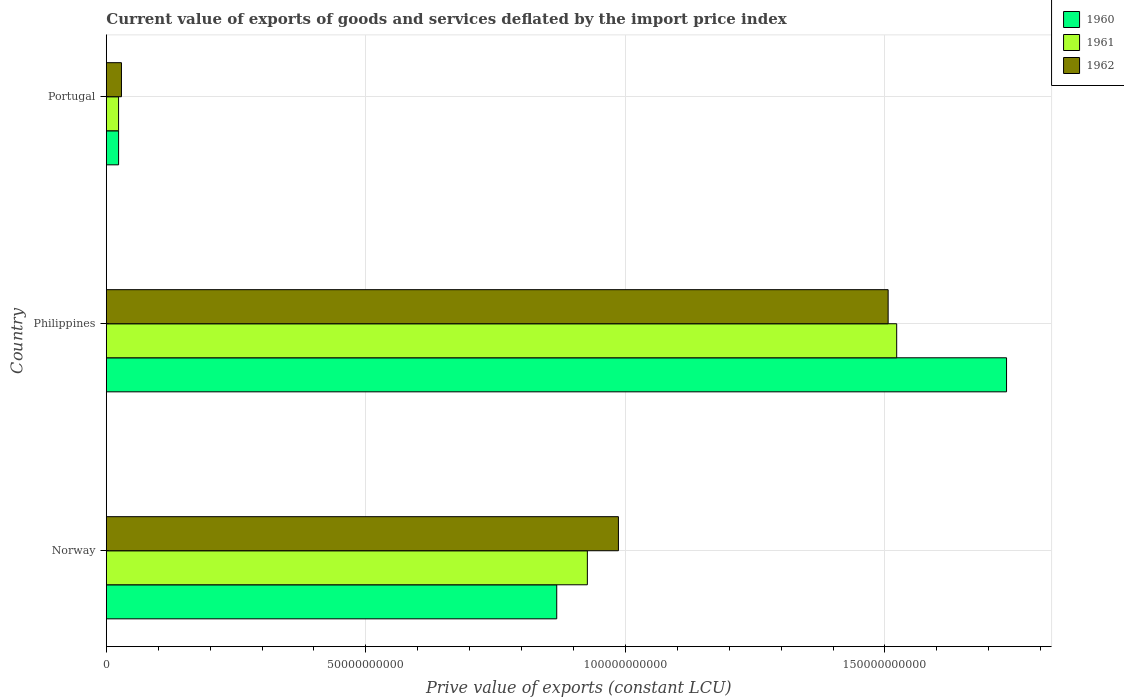How many different coloured bars are there?
Your answer should be compact. 3. Are the number of bars on each tick of the Y-axis equal?
Your answer should be very brief. Yes. How many bars are there on the 3rd tick from the top?
Your answer should be very brief. 3. What is the prive value of exports in 1962 in Portugal?
Your answer should be very brief. 2.91e+09. Across all countries, what is the maximum prive value of exports in 1961?
Ensure brevity in your answer.  1.52e+11. Across all countries, what is the minimum prive value of exports in 1962?
Offer a very short reply. 2.91e+09. In which country was the prive value of exports in 1960 maximum?
Offer a very short reply. Philippines. In which country was the prive value of exports in 1961 minimum?
Offer a very short reply. Portugal. What is the total prive value of exports in 1961 in the graph?
Your answer should be very brief. 2.47e+11. What is the difference between the prive value of exports in 1961 in Norway and that in Philippines?
Your answer should be compact. -5.96e+1. What is the difference between the prive value of exports in 1962 in Philippines and the prive value of exports in 1960 in Portugal?
Offer a terse response. 1.48e+11. What is the average prive value of exports in 1962 per country?
Keep it short and to the point. 8.41e+1. What is the difference between the prive value of exports in 1960 and prive value of exports in 1961 in Portugal?
Provide a succinct answer. 2.01e+06. What is the ratio of the prive value of exports in 1962 in Philippines to that in Portugal?
Your answer should be compact. 51.71. Is the prive value of exports in 1962 in Norway less than that in Philippines?
Your response must be concise. Yes. What is the difference between the highest and the second highest prive value of exports in 1961?
Offer a very short reply. 5.96e+1. What is the difference between the highest and the lowest prive value of exports in 1962?
Ensure brevity in your answer.  1.48e+11. How many countries are there in the graph?
Your answer should be very brief. 3. What is the difference between two consecutive major ticks on the X-axis?
Make the answer very short. 5.00e+1. What is the title of the graph?
Your answer should be compact. Current value of exports of goods and services deflated by the import price index. What is the label or title of the X-axis?
Your answer should be compact. Prive value of exports (constant LCU). What is the label or title of the Y-axis?
Your answer should be very brief. Country. What is the Prive value of exports (constant LCU) in 1960 in Norway?
Ensure brevity in your answer.  8.68e+1. What is the Prive value of exports (constant LCU) in 1961 in Norway?
Offer a terse response. 9.27e+1. What is the Prive value of exports (constant LCU) of 1962 in Norway?
Offer a terse response. 9.87e+1. What is the Prive value of exports (constant LCU) of 1960 in Philippines?
Offer a terse response. 1.73e+11. What is the Prive value of exports (constant LCU) of 1961 in Philippines?
Your response must be concise. 1.52e+11. What is the Prive value of exports (constant LCU) in 1962 in Philippines?
Your answer should be very brief. 1.51e+11. What is the Prive value of exports (constant LCU) of 1960 in Portugal?
Provide a short and direct response. 2.36e+09. What is the Prive value of exports (constant LCU) of 1961 in Portugal?
Offer a terse response. 2.36e+09. What is the Prive value of exports (constant LCU) in 1962 in Portugal?
Offer a terse response. 2.91e+09. Across all countries, what is the maximum Prive value of exports (constant LCU) of 1960?
Offer a terse response. 1.73e+11. Across all countries, what is the maximum Prive value of exports (constant LCU) of 1961?
Provide a short and direct response. 1.52e+11. Across all countries, what is the maximum Prive value of exports (constant LCU) of 1962?
Make the answer very short. 1.51e+11. Across all countries, what is the minimum Prive value of exports (constant LCU) of 1960?
Give a very brief answer. 2.36e+09. Across all countries, what is the minimum Prive value of exports (constant LCU) in 1961?
Make the answer very short. 2.36e+09. Across all countries, what is the minimum Prive value of exports (constant LCU) of 1962?
Provide a short and direct response. 2.91e+09. What is the total Prive value of exports (constant LCU) of 1960 in the graph?
Make the answer very short. 2.63e+11. What is the total Prive value of exports (constant LCU) of 1961 in the graph?
Provide a short and direct response. 2.47e+11. What is the total Prive value of exports (constant LCU) of 1962 in the graph?
Your answer should be compact. 2.52e+11. What is the difference between the Prive value of exports (constant LCU) of 1960 in Norway and that in Philippines?
Make the answer very short. -8.67e+1. What is the difference between the Prive value of exports (constant LCU) in 1961 in Norway and that in Philippines?
Your answer should be compact. -5.96e+1. What is the difference between the Prive value of exports (constant LCU) of 1962 in Norway and that in Philippines?
Your response must be concise. -5.20e+1. What is the difference between the Prive value of exports (constant LCU) of 1960 in Norway and that in Portugal?
Offer a very short reply. 8.44e+1. What is the difference between the Prive value of exports (constant LCU) in 1961 in Norway and that in Portugal?
Provide a short and direct response. 9.03e+1. What is the difference between the Prive value of exports (constant LCU) in 1962 in Norway and that in Portugal?
Your answer should be very brief. 9.57e+1. What is the difference between the Prive value of exports (constant LCU) of 1960 in Philippines and that in Portugal?
Your response must be concise. 1.71e+11. What is the difference between the Prive value of exports (constant LCU) of 1961 in Philippines and that in Portugal?
Ensure brevity in your answer.  1.50e+11. What is the difference between the Prive value of exports (constant LCU) of 1962 in Philippines and that in Portugal?
Your response must be concise. 1.48e+11. What is the difference between the Prive value of exports (constant LCU) in 1960 in Norway and the Prive value of exports (constant LCU) in 1961 in Philippines?
Give a very brief answer. -6.55e+1. What is the difference between the Prive value of exports (constant LCU) in 1960 in Norway and the Prive value of exports (constant LCU) in 1962 in Philippines?
Provide a short and direct response. -6.39e+1. What is the difference between the Prive value of exports (constant LCU) of 1961 in Norway and the Prive value of exports (constant LCU) of 1962 in Philippines?
Ensure brevity in your answer.  -5.79e+1. What is the difference between the Prive value of exports (constant LCU) in 1960 in Norway and the Prive value of exports (constant LCU) in 1961 in Portugal?
Provide a short and direct response. 8.44e+1. What is the difference between the Prive value of exports (constant LCU) in 1960 in Norway and the Prive value of exports (constant LCU) in 1962 in Portugal?
Offer a very short reply. 8.39e+1. What is the difference between the Prive value of exports (constant LCU) in 1961 in Norway and the Prive value of exports (constant LCU) in 1962 in Portugal?
Your response must be concise. 8.98e+1. What is the difference between the Prive value of exports (constant LCU) of 1960 in Philippines and the Prive value of exports (constant LCU) of 1961 in Portugal?
Provide a succinct answer. 1.71e+11. What is the difference between the Prive value of exports (constant LCU) in 1960 in Philippines and the Prive value of exports (constant LCU) in 1962 in Portugal?
Make the answer very short. 1.71e+11. What is the difference between the Prive value of exports (constant LCU) in 1961 in Philippines and the Prive value of exports (constant LCU) in 1962 in Portugal?
Make the answer very short. 1.49e+11. What is the average Prive value of exports (constant LCU) in 1960 per country?
Ensure brevity in your answer.  8.75e+1. What is the average Prive value of exports (constant LCU) in 1961 per country?
Make the answer very short. 8.24e+1. What is the average Prive value of exports (constant LCU) in 1962 per country?
Offer a very short reply. 8.41e+1. What is the difference between the Prive value of exports (constant LCU) of 1960 and Prive value of exports (constant LCU) of 1961 in Norway?
Offer a very short reply. -5.90e+09. What is the difference between the Prive value of exports (constant LCU) of 1960 and Prive value of exports (constant LCU) of 1962 in Norway?
Your answer should be compact. -1.19e+1. What is the difference between the Prive value of exports (constant LCU) of 1961 and Prive value of exports (constant LCU) of 1962 in Norway?
Your answer should be very brief. -5.98e+09. What is the difference between the Prive value of exports (constant LCU) of 1960 and Prive value of exports (constant LCU) of 1961 in Philippines?
Provide a succinct answer. 2.12e+1. What is the difference between the Prive value of exports (constant LCU) of 1960 and Prive value of exports (constant LCU) of 1962 in Philippines?
Offer a terse response. 2.28e+1. What is the difference between the Prive value of exports (constant LCU) in 1961 and Prive value of exports (constant LCU) in 1962 in Philippines?
Ensure brevity in your answer.  1.65e+09. What is the difference between the Prive value of exports (constant LCU) of 1960 and Prive value of exports (constant LCU) of 1961 in Portugal?
Your answer should be compact. 2.01e+06. What is the difference between the Prive value of exports (constant LCU) of 1960 and Prive value of exports (constant LCU) of 1962 in Portugal?
Your answer should be compact. -5.51e+08. What is the difference between the Prive value of exports (constant LCU) in 1961 and Prive value of exports (constant LCU) in 1962 in Portugal?
Your answer should be compact. -5.53e+08. What is the ratio of the Prive value of exports (constant LCU) of 1960 in Norway to that in Philippines?
Your answer should be very brief. 0.5. What is the ratio of the Prive value of exports (constant LCU) of 1961 in Norway to that in Philippines?
Offer a terse response. 0.61. What is the ratio of the Prive value of exports (constant LCU) of 1962 in Norway to that in Philippines?
Give a very brief answer. 0.66. What is the ratio of the Prive value of exports (constant LCU) of 1960 in Norway to that in Portugal?
Offer a terse response. 36.73. What is the ratio of the Prive value of exports (constant LCU) of 1961 in Norway to that in Portugal?
Your answer should be very brief. 39.27. What is the ratio of the Prive value of exports (constant LCU) in 1962 in Norway to that in Portugal?
Give a very brief answer. 33.87. What is the ratio of the Prive value of exports (constant LCU) of 1960 in Philippines to that in Portugal?
Your response must be concise. 73.42. What is the ratio of the Prive value of exports (constant LCU) of 1961 in Philippines to that in Portugal?
Offer a terse response. 64.52. What is the ratio of the Prive value of exports (constant LCU) of 1962 in Philippines to that in Portugal?
Ensure brevity in your answer.  51.71. What is the difference between the highest and the second highest Prive value of exports (constant LCU) in 1960?
Your answer should be compact. 8.67e+1. What is the difference between the highest and the second highest Prive value of exports (constant LCU) in 1961?
Provide a succinct answer. 5.96e+1. What is the difference between the highest and the second highest Prive value of exports (constant LCU) in 1962?
Your response must be concise. 5.20e+1. What is the difference between the highest and the lowest Prive value of exports (constant LCU) in 1960?
Provide a short and direct response. 1.71e+11. What is the difference between the highest and the lowest Prive value of exports (constant LCU) in 1961?
Make the answer very short. 1.50e+11. What is the difference between the highest and the lowest Prive value of exports (constant LCU) of 1962?
Ensure brevity in your answer.  1.48e+11. 